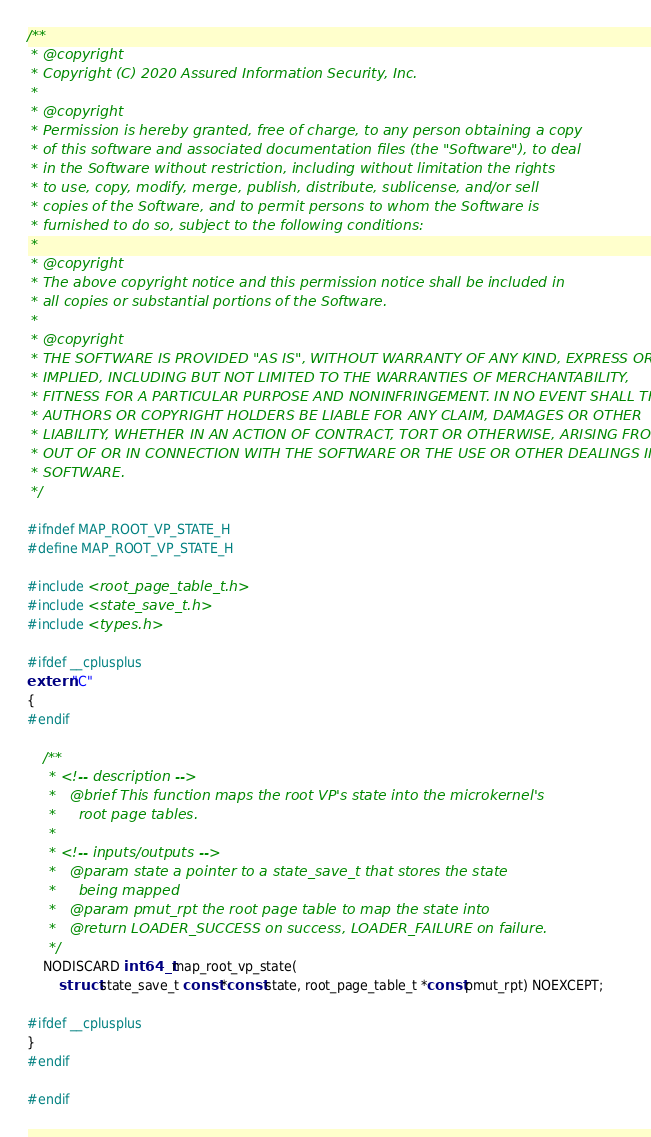Convert code to text. <code><loc_0><loc_0><loc_500><loc_500><_C_>/**
 * @copyright
 * Copyright (C) 2020 Assured Information Security, Inc.
 *
 * @copyright
 * Permission is hereby granted, free of charge, to any person obtaining a copy
 * of this software and associated documentation files (the "Software"), to deal
 * in the Software without restriction, including without limitation the rights
 * to use, copy, modify, merge, publish, distribute, sublicense, and/or sell
 * copies of the Software, and to permit persons to whom the Software is
 * furnished to do so, subject to the following conditions:
 *
 * @copyright
 * The above copyright notice and this permission notice shall be included in
 * all copies or substantial portions of the Software.
 *
 * @copyright
 * THE SOFTWARE IS PROVIDED "AS IS", WITHOUT WARRANTY OF ANY KIND, EXPRESS OR
 * IMPLIED, INCLUDING BUT NOT LIMITED TO THE WARRANTIES OF MERCHANTABILITY,
 * FITNESS FOR A PARTICULAR PURPOSE AND NONINFRINGEMENT. IN NO EVENT SHALL THE
 * AUTHORS OR COPYRIGHT HOLDERS BE LIABLE FOR ANY CLAIM, DAMAGES OR OTHER
 * LIABILITY, WHETHER IN AN ACTION OF CONTRACT, TORT OR OTHERWISE, ARISING FROM,
 * OUT OF OR IN CONNECTION WITH THE SOFTWARE OR THE USE OR OTHER DEALINGS IN THE
 * SOFTWARE.
 */

#ifndef MAP_ROOT_VP_STATE_H
#define MAP_ROOT_VP_STATE_H

#include <root_page_table_t.h>
#include <state_save_t.h>
#include <types.h>

#ifdef __cplusplus
extern "C"
{
#endif

    /**
     * <!-- description -->
     *   @brief This function maps the root VP's state into the microkernel's
     *     root page tables.
     *
     * <!-- inputs/outputs -->
     *   @param state a pointer to a state_save_t that stores the state
     *     being mapped
     *   @param pmut_rpt the root page table to map the state into
     *   @return LOADER_SUCCESS on success, LOADER_FAILURE on failure.
     */
    NODISCARD int64_t map_root_vp_state(
        struct state_save_t const *const state, root_page_table_t *const pmut_rpt) NOEXCEPT;

#ifdef __cplusplus
}
#endif

#endif
</code> 